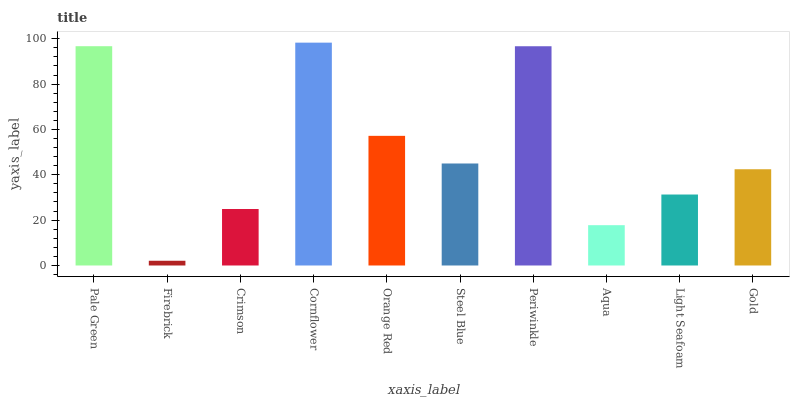Is Firebrick the minimum?
Answer yes or no. Yes. Is Cornflower the maximum?
Answer yes or no. Yes. Is Crimson the minimum?
Answer yes or no. No. Is Crimson the maximum?
Answer yes or no. No. Is Crimson greater than Firebrick?
Answer yes or no. Yes. Is Firebrick less than Crimson?
Answer yes or no. Yes. Is Firebrick greater than Crimson?
Answer yes or no. No. Is Crimson less than Firebrick?
Answer yes or no. No. Is Steel Blue the high median?
Answer yes or no. Yes. Is Gold the low median?
Answer yes or no. Yes. Is Crimson the high median?
Answer yes or no. No. Is Steel Blue the low median?
Answer yes or no. No. 